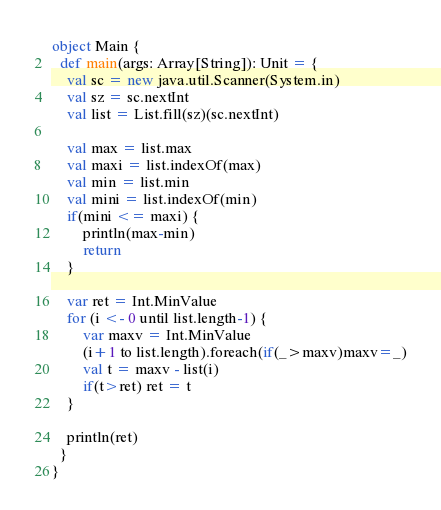Convert code to text. <code><loc_0><loc_0><loc_500><loc_500><_Scala_>object Main {
  def main(args: Array[String]): Unit = {
    val sc = new java.util.Scanner(System.in)
    val sz = sc.nextInt
    val list = List.fill(sz)(sc.nextInt)

    val max = list.max
    val maxi = list.indexOf(max)
    val min = list.min
    val mini = list.indexOf(min)
    if(mini <= maxi) {
        println(max-min)
        return
    }

    var ret = Int.MinValue
    for (i <- 0 until list.length-1) {
        var maxv = Int.MinValue
        (i+1 to list.length).foreach(if(_>maxv)maxv=_)
        val t = maxv - list(i)
        if(t>ret) ret = t
    }
 
    println(ret)
  }
}</code> 